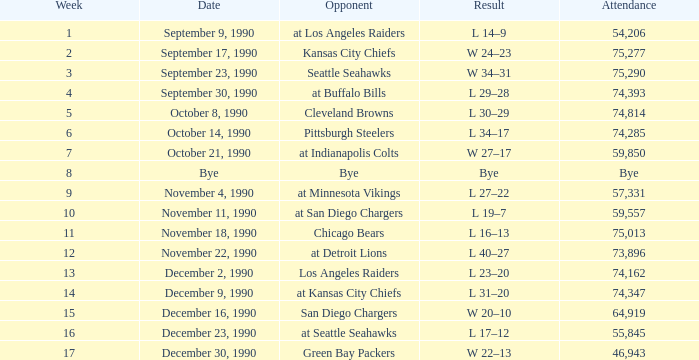Which day recorded an attendance of 74,285? October 14, 1990. 